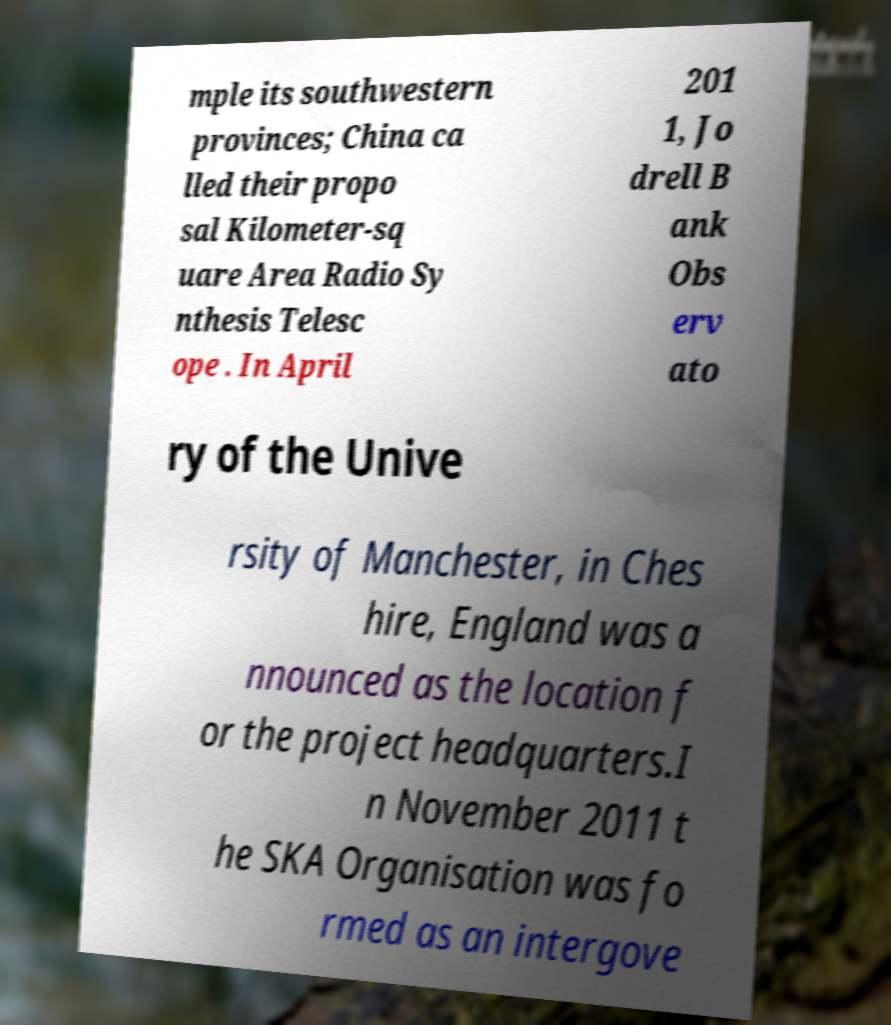What messages or text are displayed in this image? I need them in a readable, typed format. mple its southwestern provinces; China ca lled their propo sal Kilometer-sq uare Area Radio Sy nthesis Telesc ope . In April 201 1, Jo drell B ank Obs erv ato ry of the Unive rsity of Manchester, in Ches hire, England was a nnounced as the location f or the project headquarters.I n November 2011 t he SKA Organisation was fo rmed as an intergove 